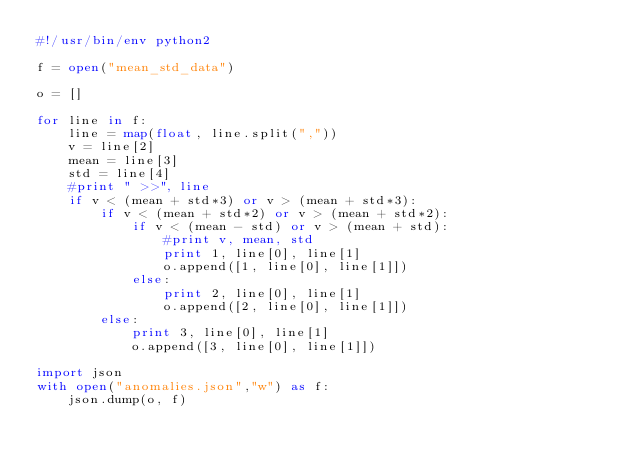<code> <loc_0><loc_0><loc_500><loc_500><_Python_>#!/usr/bin/env python2

f = open("mean_std_data")

o = []

for line in f:
    line = map(float, line.split(","))
    v = line[2]
    mean = line[3]
    std = line[4]
    #print " >>", line
    if v < (mean + std*3) or v > (mean + std*3):
        if v < (mean + std*2) or v > (mean + std*2):
            if v < (mean - std) or v > (mean + std):
                #print v, mean, std
                print 1, line[0], line[1]
                o.append([1, line[0], line[1]])
            else:
                print 2, line[0], line[1]
                o.append([2, line[0], line[1]])
        else:
            print 3, line[0], line[1]
            o.append([3, line[0], line[1]])

import json
with open("anomalies.json","w") as f:
    json.dump(o, f)
</code> 